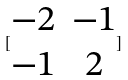Convert formula to latex. <formula><loc_0><loc_0><loc_500><loc_500>[ \begin{matrix} - 2 & - 1 \\ - 1 & 2 \end{matrix} ]</formula> 